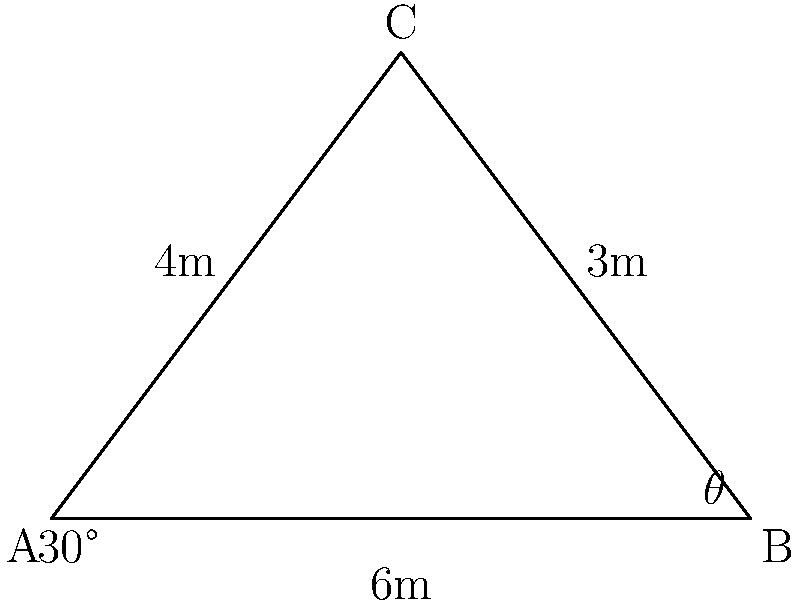As a patrol officer, you need to use a non-lethal projectile to subdue a suspect. The suspect is located 6 meters away from you and 4 meters above ground level. If the projectile is fired at a 30° angle from the horizontal, what should be the angle of deflection ($\theta$) for the projectile to hit the suspect? To solve this problem, we'll use trigonometry:

1) First, we need to find the angle formed by the line from the officer to the suspect (AC) and the horizontal (AB).

2) We can use the tangent function to find this angle:
   $\tan(\alpha) = \frac{\text{opposite}}{\text{adjacent}} = \frac{4}{6} = \frac{2}{3}$

3) Therefore, $\alpha = \arctan(\frac{2}{3}) \approx 33.69°$

4) The angle of deflection $\theta$ is the difference between this angle and the firing angle:
   $\theta = \alpha - 30°$

5) Calculating:
   $\theta = 33.69° - 30° = 3.69°$

6) Rounding to the nearest degree:
   $\theta \approx 4°$

This means the projectile needs to be deflected upwards by approximately 4° from the initial 30° firing angle to hit the suspect.
Answer: 4° 